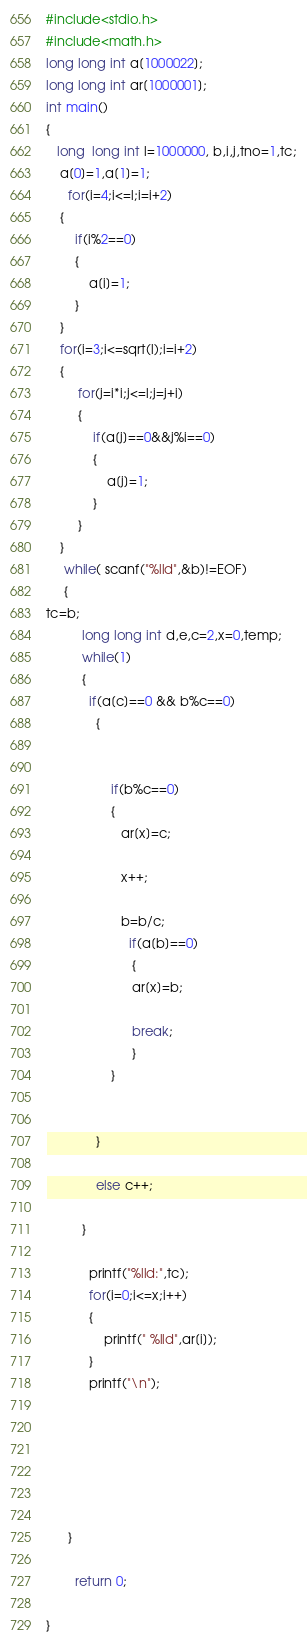Convert code to text. <code><loc_0><loc_0><loc_500><loc_500><_C_>
#include<stdio.h>
#include<math.h>
long long int a[1000022];
long long int ar[1000001];
int main()
{
   long  long int l=1000000, b,i,j,tno=1,tc;
    a[0]=1,a[1]=1;
      for(i=4;i<=l;i=i+2)
    {
        if(i%2==0)
        {
            a[i]=1;
        }
    }
    for(i=3;i<=sqrt(l);i=i+2)
    {
         for(j=i*i;j<=l;j=j+i)
         {
             if(a[j]==0&&j%i==0)
             {
                 a[j]=1;
             }
         }
    }
     while( scanf("%lld",&b)!=EOF)
     {
tc=b;
          long long int d,e,c=2,x=0,temp;
          while(1)
          {
            if(a[c]==0 && b%c==0)
              {


                  if(b%c==0)
                  {
                     ar[x]=c;

                     x++;

                     b=b/c;
                       if(a[b]==0)
                        {
                        ar[x]=b;

                        break;
                        }
                  }


              }

              else c++;

          }

            printf("%lld:",tc);
            for(i=0;i<=x;i++)
            {
                printf(" %lld",ar[i]);
            }
            printf("\n");






      }

        return 0;

}</code> 